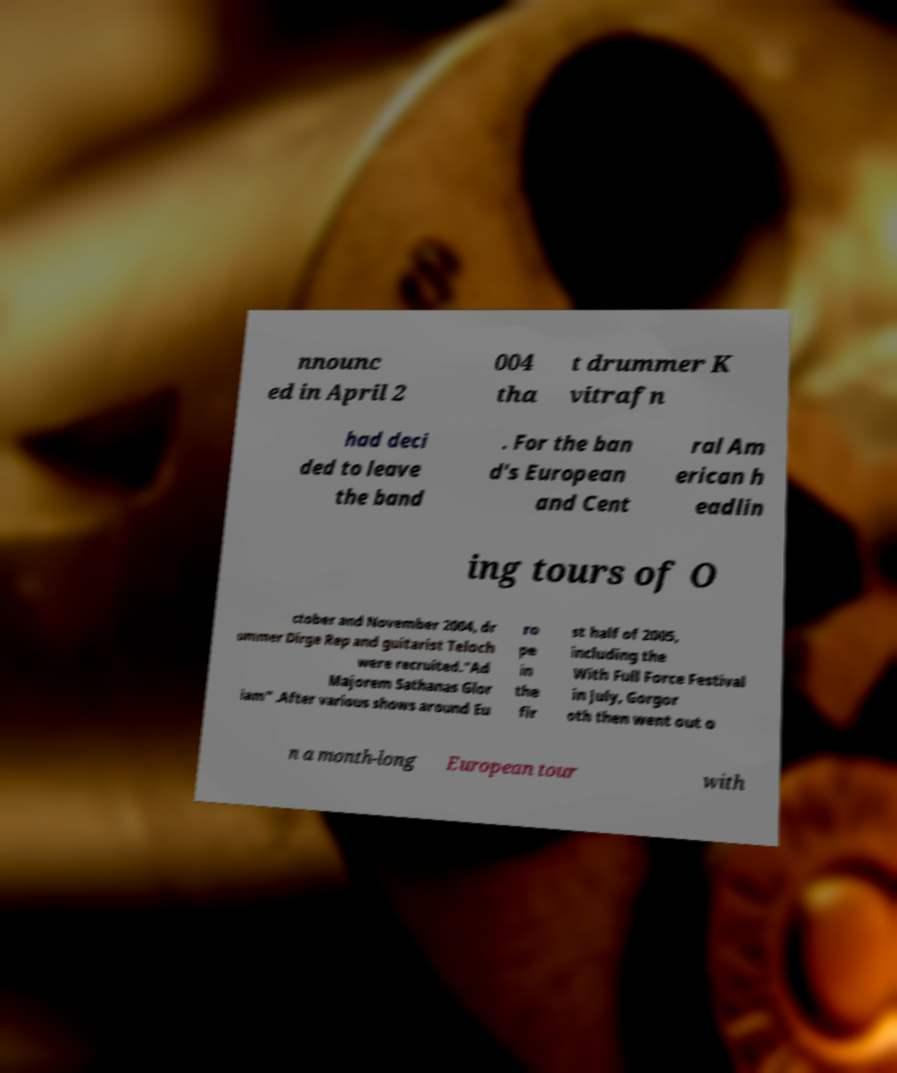Could you extract and type out the text from this image? nnounc ed in April 2 004 tha t drummer K vitrafn had deci ded to leave the band . For the ban d's European and Cent ral Am erican h eadlin ing tours of O ctober and November 2004, dr ummer Dirge Rep and guitarist Teloch were recruited."Ad Majorem Sathanas Glor iam" .After various shows around Eu ro pe in the fir st half of 2005, including the With Full Force Festival in July, Gorgor oth then went out o n a month-long European tour with 